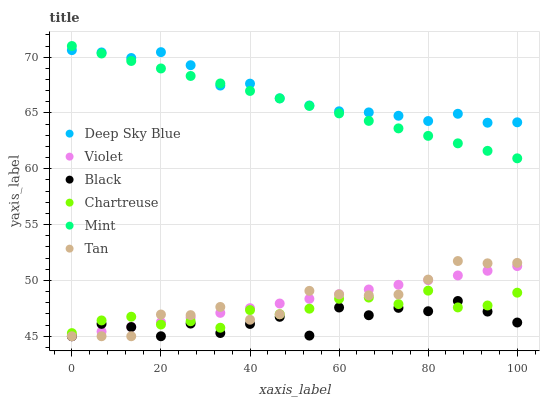Does Black have the minimum area under the curve?
Answer yes or no. Yes. Does Deep Sky Blue have the maximum area under the curve?
Answer yes or no. Yes. Does Deep Sky Blue have the minimum area under the curve?
Answer yes or no. No. Does Black have the maximum area under the curve?
Answer yes or no. No. Is Violet the smoothest?
Answer yes or no. Yes. Is Black the roughest?
Answer yes or no. Yes. Is Deep Sky Blue the smoothest?
Answer yes or no. No. Is Deep Sky Blue the roughest?
Answer yes or no. No. Does Black have the lowest value?
Answer yes or no. Yes. Does Deep Sky Blue have the lowest value?
Answer yes or no. No. Does Mint have the highest value?
Answer yes or no. Yes. Does Deep Sky Blue have the highest value?
Answer yes or no. No. Is Black less than Mint?
Answer yes or no. Yes. Is Mint greater than Black?
Answer yes or no. Yes. Does Violet intersect Black?
Answer yes or no. Yes. Is Violet less than Black?
Answer yes or no. No. Is Violet greater than Black?
Answer yes or no. No. Does Black intersect Mint?
Answer yes or no. No. 